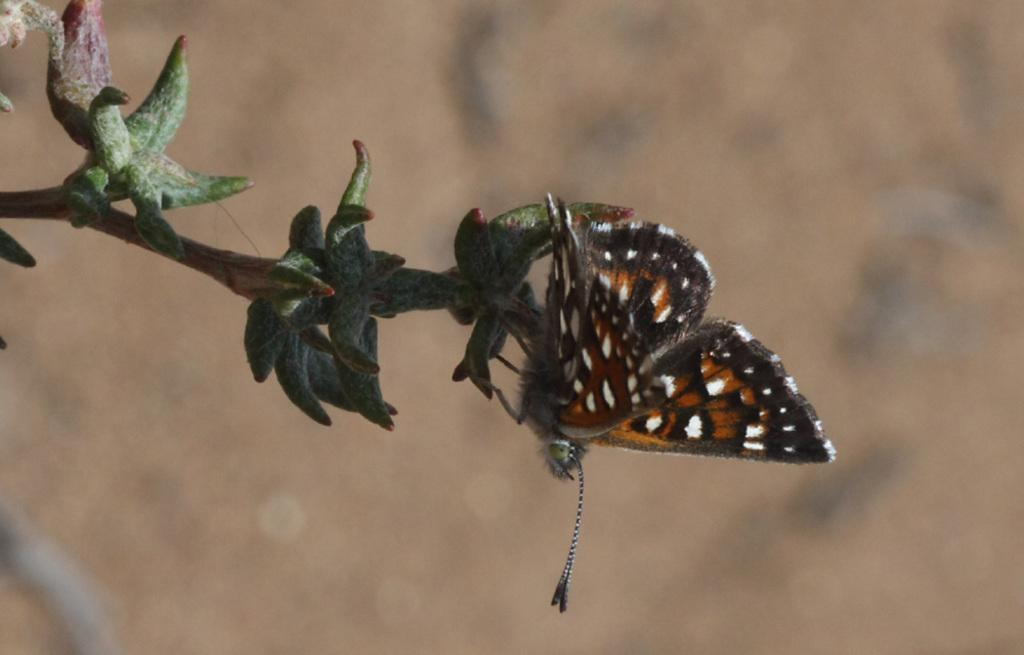What is the main subject of the image? There is a butterfly in the image. Can you describe the color pattern of the butterfly? The butterfly is brown, black, and white in color. What other object is present in the image? There is a tree in the image. What is the color of the tree? The tree is green in color. How would you describe the background of the image? The background of the image is blurry and brown in color. What type of texture can be seen on the linen in the image? There is no linen present in the image; it features a butterfly and a tree. How many pickles are visible on the tree in the image? There are no pickles present in the image; it features a butterfly and a tree. 